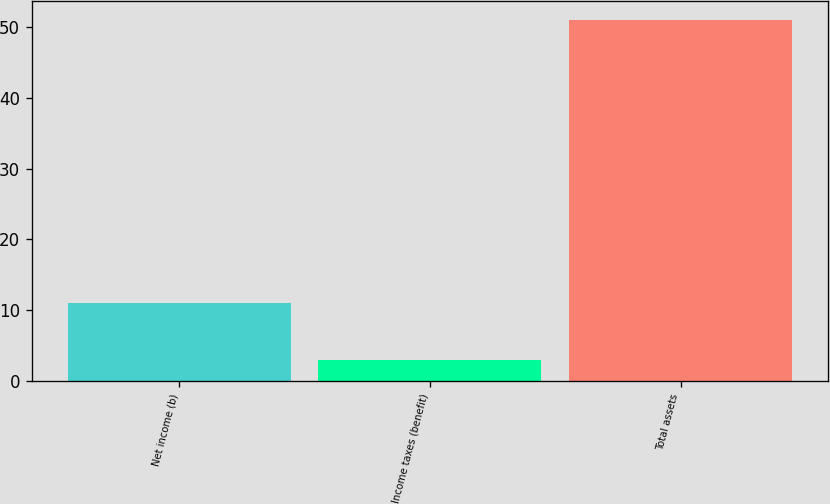<chart> <loc_0><loc_0><loc_500><loc_500><bar_chart><fcel>Net income (b)<fcel>Income taxes (benefit)<fcel>Total assets<nl><fcel>11<fcel>3<fcel>51<nl></chart> 